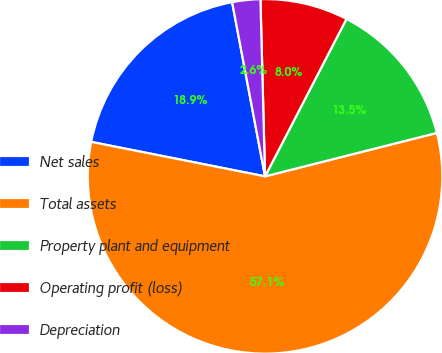Convert chart to OTSL. <chart><loc_0><loc_0><loc_500><loc_500><pie_chart><fcel>Net sales<fcel>Total assets<fcel>Property plant and equipment<fcel>Operating profit (loss)<fcel>Depreciation<nl><fcel>18.91%<fcel>57.06%<fcel>13.46%<fcel>8.01%<fcel>2.56%<nl></chart> 